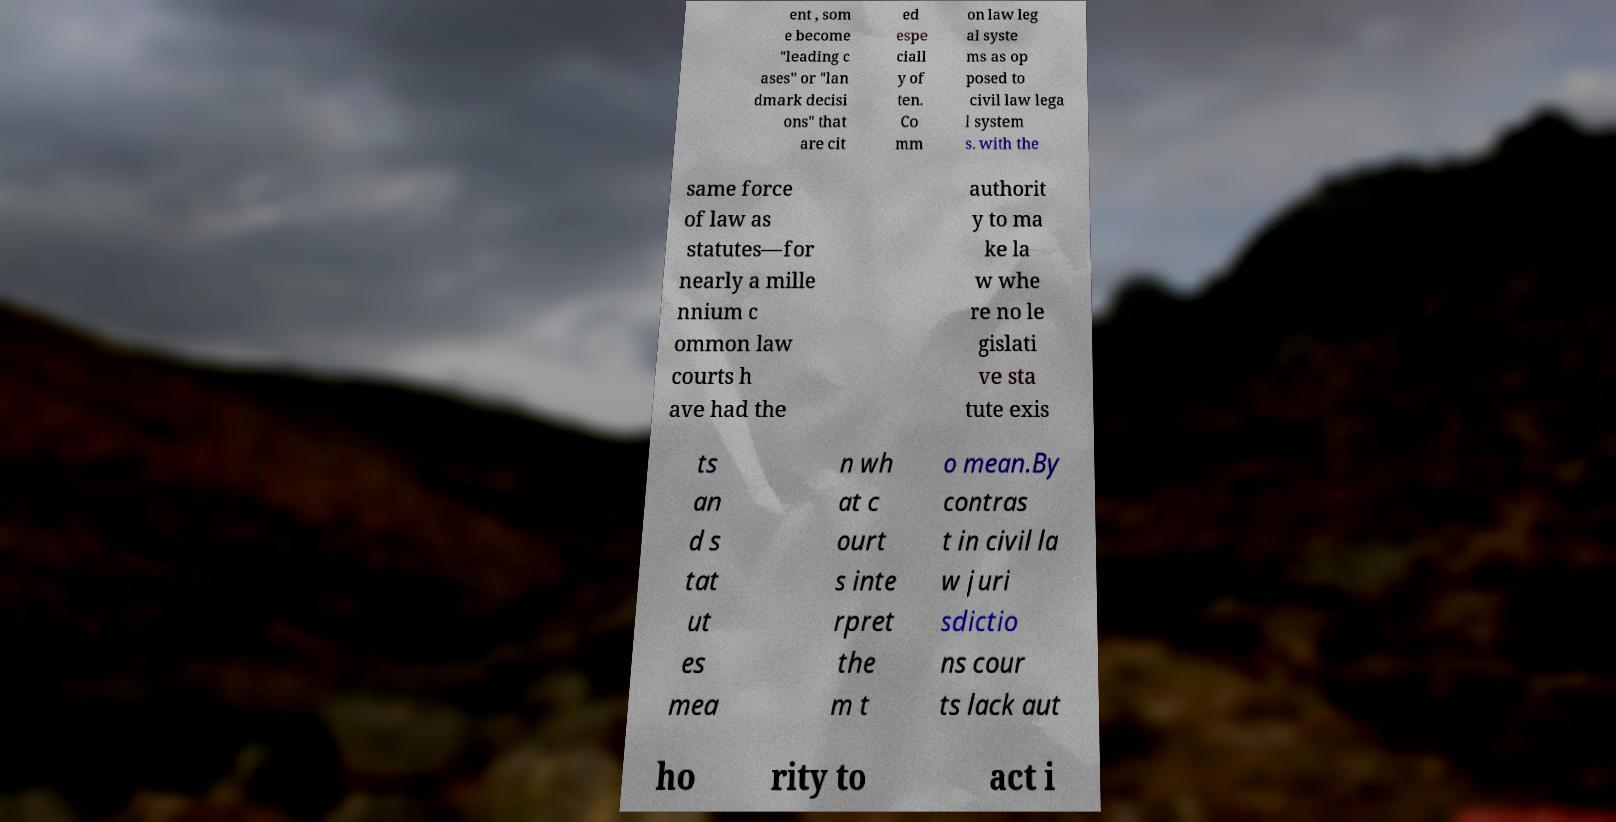Please identify and transcribe the text found in this image. ent , som e become "leading c ases" or "lan dmark decisi ons" that are cit ed espe ciall y of ten. Co mm on law leg al syste ms as op posed to civil law lega l system s. with the same force of law as statutes—for nearly a mille nnium c ommon law courts h ave had the authorit y to ma ke la w whe re no le gislati ve sta tute exis ts an d s tat ut es mea n wh at c ourt s inte rpret the m t o mean.By contras t in civil la w juri sdictio ns cour ts lack aut ho rity to act i 